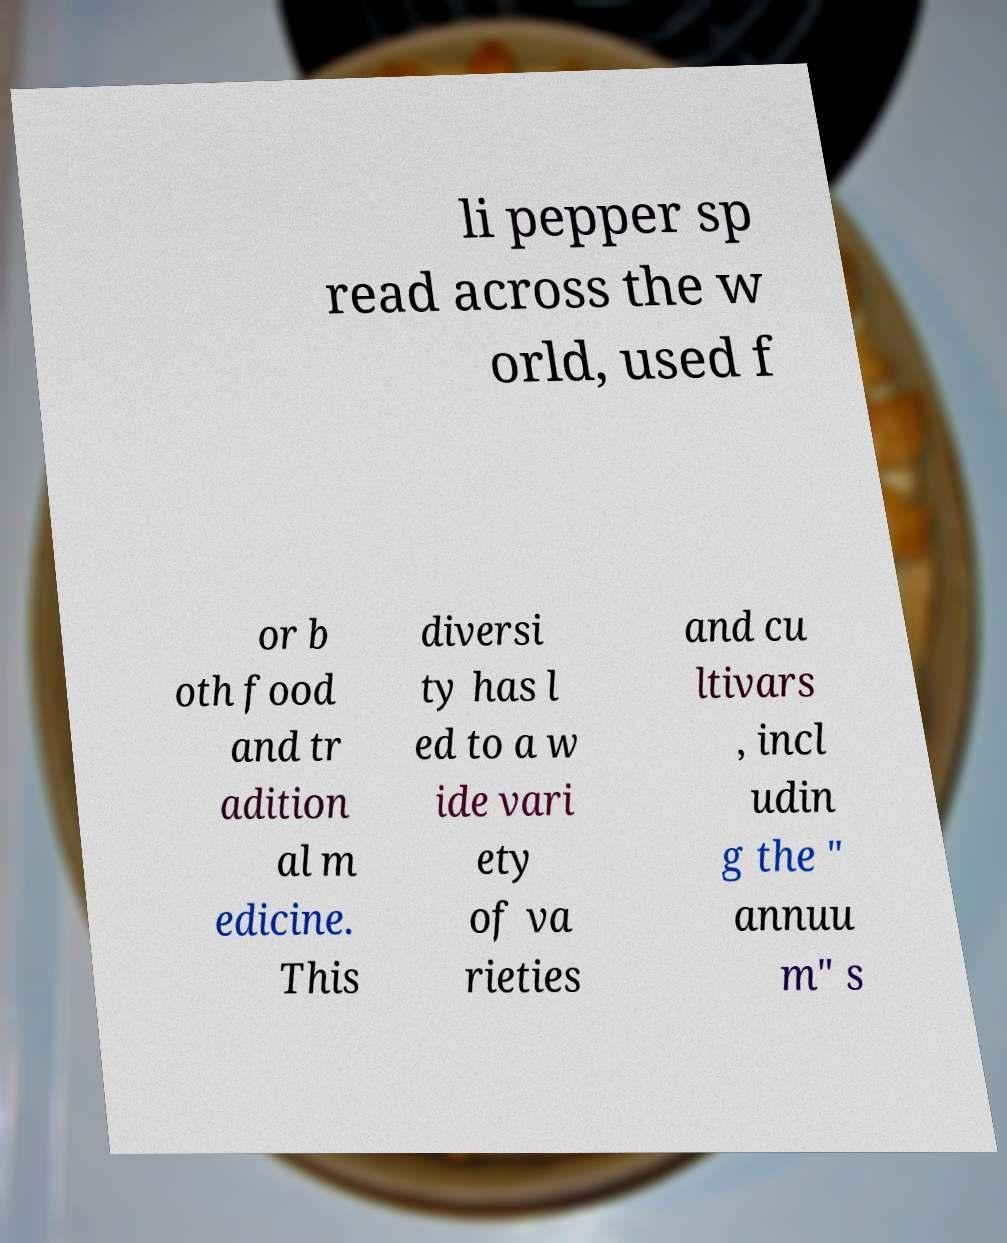What messages or text are displayed in this image? I need them in a readable, typed format. li pepper sp read across the w orld, used f or b oth food and tr adition al m edicine. This diversi ty has l ed to a w ide vari ety of va rieties and cu ltivars , incl udin g the " annuu m" s 